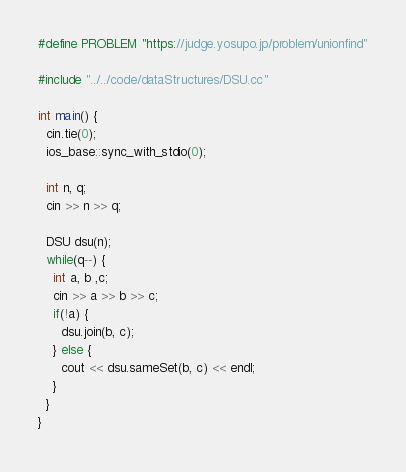Convert code to text. <code><loc_0><loc_0><loc_500><loc_500><_C++_>#define PROBLEM "https://judge.yosupo.jp/problem/unionfind"

#include "../../code/dataStructures/DSU.cc"

int main() {
  cin.tie(0);
  ios_base::sync_with_stdio(0);
  
  int n, q;
  cin >> n >> q;
  
  DSU dsu(n);
  while(q--) {
    int a, b ,c;
    cin >> a >> b >> c;
    if(!a) {
      dsu.join(b, c);
    } else {
      cout << dsu.sameSet(b, c) << endl;
    }
  }
}
</code> 